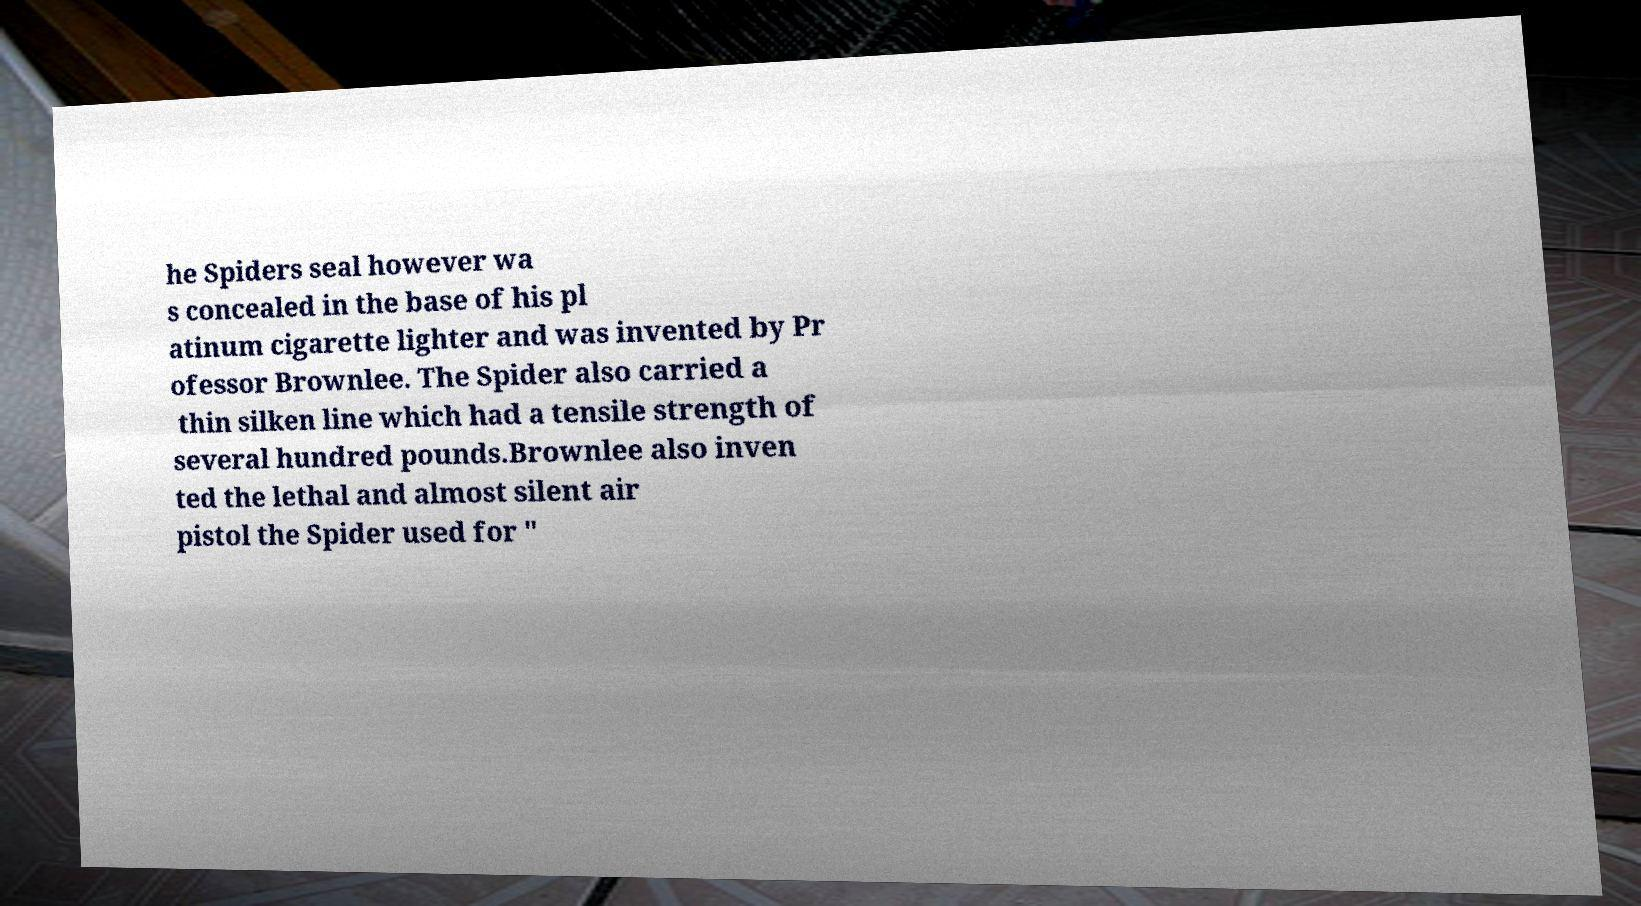For documentation purposes, I need the text within this image transcribed. Could you provide that? he Spiders seal however wa s concealed in the base of his pl atinum cigarette lighter and was invented by Pr ofessor Brownlee. The Spider also carried a thin silken line which had a tensile strength of several hundred pounds.Brownlee also inven ted the lethal and almost silent air pistol the Spider used for " 